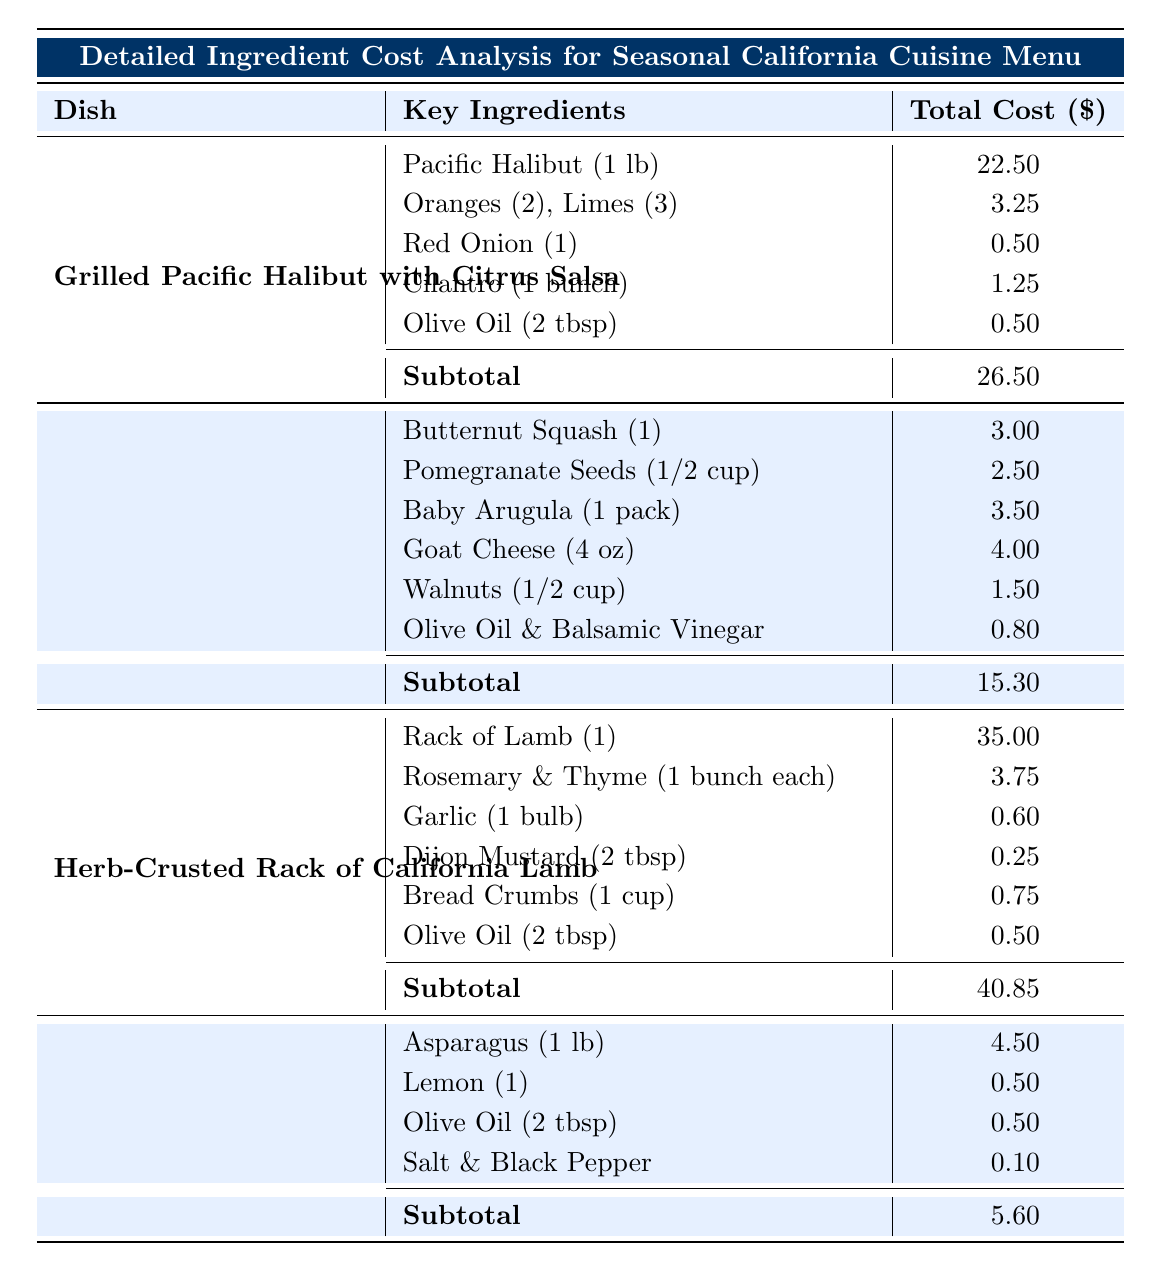What is the total cost of the dish "Grilled Pacific Halibut with Citrus Salsa"? The table shows that the total cost for the dish "Grilled Pacific Halibut with Citrus Salsa" is presented in the last column for that dish. The total cost is directly mentioned as 26.50.
Answer: 26.50 Which ingredient has the highest unit cost in the menu? By examining the unit costs listed for each ingredient across all dishes, the "Rack of Lamb" at 35.00 has the highest unit cost compared to other ingredients, such as Pacific Halibut at 22.50 and Goat Cheese at 4.00.
Answer: Rack of Lamb How much does the Olive Oil cost when included in the "Grilled Asparagus with Lemon Zest"? The cost of Olive Oil in "Grilled Asparagus with Lemon Zest" is listed as 0.50 for 2 tbsp. This amount can be directly retrieved from the table where Olive Oil is listed among the ingredients for that dish.
Answer: 0.50 What is the combined total cost of the ingredients used in "Herb-Crusted Rack of California Lamb" and "Grilled Pacific Halibut with Citrus Salsa"? First, we note the total costs for both dishes: "Herb-Crusted Rack of California Lamb" is 40.85 and "Grilled Pacific Halibut with Citrus Salsa" is 26.50. Adding these together gives us a total of 40.85 + 26.50 = 67.35.
Answer: 67.35 Is the total cost of the "Roasted Butternut Squash Salad with Pomegranate Vinaigrette" less than 20? The total cost of the dish "Roasted Butternut Squash Salad with Pomegranate Vinaigrette" is 15.30. Comparing this value to 20 shows it is indeed less than 20, confirming the statement is true.
Answer: Yes What is the average cost of all the dishes listed in the menu? The total costs of the dishes are 26.50 (Halibut) + 15.30 (Salad) + 40.85 (Lamb) + 5.60 (Asparagus) = 88.25 for four dishes. The average is calculated as 88.25 / 4 = 22.06.
Answer: 22.06 What is the total ingredient cost for the "Grilled Asparagus with Lemon Zest"? The total cost, as indicated in the table for "Grilled Asparagus with Lemon Zest," is directly provided as 5.60, which encompasses all the ingredients for that dish.
Answer: 5.60 Are there any ingredients in the "Roasted Butternut Squash Salad with Pomegranate Vinaigrette" that also appear in the "Grilled Pacific Halibut with Citrus Salsa"? A review of both dishes shows that Olive Oil is the only ingredient that appears in both dishes. Therefore, the answer is yes, confirming the presence of a shared ingredient.
Answer: Yes 